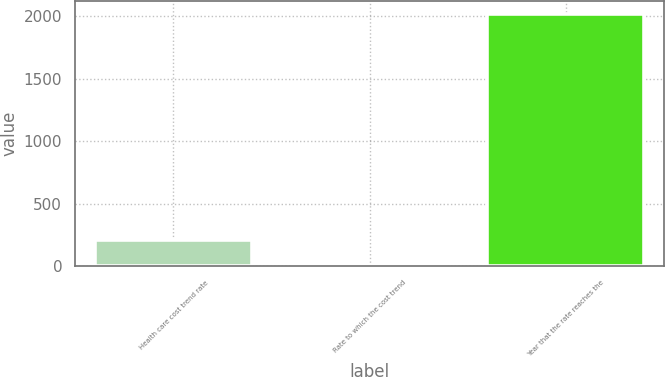Convert chart to OTSL. <chart><loc_0><loc_0><loc_500><loc_500><bar_chart><fcel>Health care cost trend rate<fcel>Rate to which the cost trend<fcel>Year that the rate reaches the<nl><fcel>206.05<fcel>4.5<fcel>2020<nl></chart> 